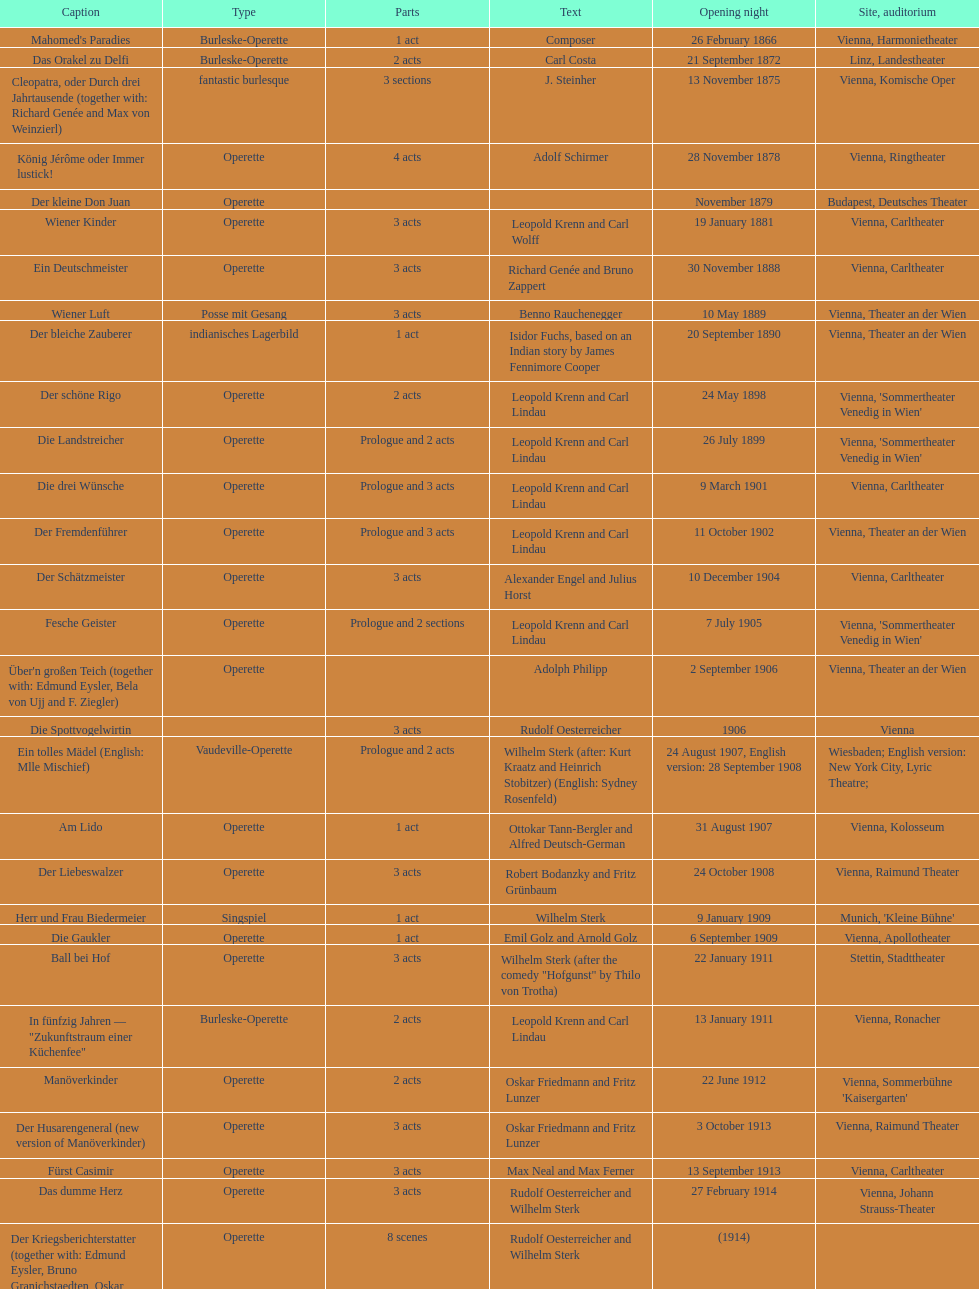What was the year of the last title? 1958. 